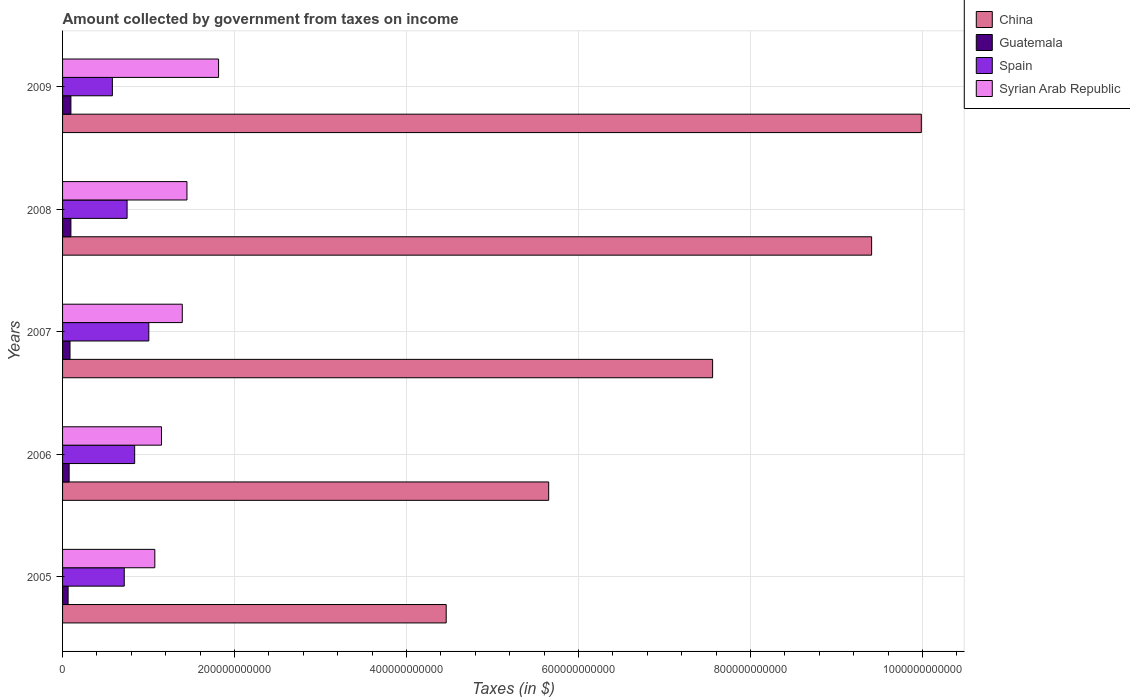How many different coloured bars are there?
Provide a short and direct response. 4. How many groups of bars are there?
Keep it short and to the point. 5. Are the number of bars on each tick of the Y-axis equal?
Make the answer very short. Yes. How many bars are there on the 5th tick from the top?
Offer a terse response. 4. How many bars are there on the 2nd tick from the bottom?
Ensure brevity in your answer.  4. What is the amount collected by government from taxes on income in Spain in 2005?
Ensure brevity in your answer.  7.17e+1. Across all years, what is the maximum amount collected by government from taxes on income in Syrian Arab Republic?
Offer a terse response. 1.81e+11. Across all years, what is the minimum amount collected by government from taxes on income in Guatemala?
Ensure brevity in your answer.  6.44e+09. In which year was the amount collected by government from taxes on income in Spain maximum?
Provide a succinct answer. 2007. In which year was the amount collected by government from taxes on income in China minimum?
Your response must be concise. 2005. What is the total amount collected by government from taxes on income in Spain in the graph?
Offer a terse response. 3.89e+11. What is the difference between the amount collected by government from taxes on income in Guatemala in 2006 and that in 2008?
Ensure brevity in your answer.  -2.05e+09. What is the difference between the amount collected by government from taxes on income in China in 2006 and the amount collected by government from taxes on income in Syrian Arab Republic in 2008?
Keep it short and to the point. 4.21e+11. What is the average amount collected by government from taxes on income in Guatemala per year?
Give a very brief answer. 8.43e+09. In the year 2008, what is the difference between the amount collected by government from taxes on income in Guatemala and amount collected by government from taxes on income in Spain?
Give a very brief answer. -6.53e+1. In how many years, is the amount collected by government from taxes on income in Guatemala greater than 640000000000 $?
Offer a terse response. 0. What is the ratio of the amount collected by government from taxes on income in Spain in 2005 to that in 2007?
Your response must be concise. 0.72. What is the difference between the highest and the second highest amount collected by government from taxes on income in Syrian Arab Republic?
Your response must be concise. 3.68e+1. What is the difference between the highest and the lowest amount collected by government from taxes on income in China?
Make the answer very short. 5.52e+11. What does the 2nd bar from the bottom in 2006 represents?
Provide a short and direct response. Guatemala. How many bars are there?
Your answer should be compact. 20. Are all the bars in the graph horizontal?
Make the answer very short. Yes. How many years are there in the graph?
Provide a short and direct response. 5. What is the difference between two consecutive major ticks on the X-axis?
Make the answer very short. 2.00e+11. Are the values on the major ticks of X-axis written in scientific E-notation?
Your response must be concise. No. Does the graph contain grids?
Offer a very short reply. Yes. How many legend labels are there?
Make the answer very short. 4. How are the legend labels stacked?
Give a very brief answer. Vertical. What is the title of the graph?
Offer a very short reply. Amount collected by government from taxes on income. Does "Hungary" appear as one of the legend labels in the graph?
Give a very brief answer. No. What is the label or title of the X-axis?
Make the answer very short. Taxes (in $). What is the Taxes (in $) in China in 2005?
Your answer should be very brief. 4.46e+11. What is the Taxes (in $) of Guatemala in 2005?
Ensure brevity in your answer.  6.44e+09. What is the Taxes (in $) of Spain in 2005?
Provide a succinct answer. 7.17e+1. What is the Taxes (in $) in Syrian Arab Republic in 2005?
Offer a terse response. 1.07e+11. What is the Taxes (in $) of China in 2006?
Your response must be concise. 5.65e+11. What is the Taxes (in $) in Guatemala in 2006?
Make the answer very short. 7.65e+09. What is the Taxes (in $) in Spain in 2006?
Provide a succinct answer. 8.38e+1. What is the Taxes (in $) of Syrian Arab Republic in 2006?
Provide a succinct answer. 1.15e+11. What is the Taxes (in $) of China in 2007?
Ensure brevity in your answer.  7.56e+11. What is the Taxes (in $) in Guatemala in 2007?
Offer a very short reply. 8.65e+09. What is the Taxes (in $) in Spain in 2007?
Ensure brevity in your answer.  1.00e+11. What is the Taxes (in $) of Syrian Arab Republic in 2007?
Give a very brief answer. 1.39e+11. What is the Taxes (in $) in China in 2008?
Your response must be concise. 9.41e+11. What is the Taxes (in $) in Guatemala in 2008?
Provide a succinct answer. 9.70e+09. What is the Taxes (in $) of Spain in 2008?
Your answer should be very brief. 7.50e+1. What is the Taxes (in $) of Syrian Arab Republic in 2008?
Your answer should be compact. 1.45e+11. What is the Taxes (in $) of China in 2009?
Give a very brief answer. 9.99e+11. What is the Taxes (in $) in Guatemala in 2009?
Provide a short and direct response. 9.71e+09. What is the Taxes (in $) of Spain in 2009?
Offer a very short reply. 5.79e+1. What is the Taxes (in $) in Syrian Arab Republic in 2009?
Keep it short and to the point. 1.81e+11. Across all years, what is the maximum Taxes (in $) in China?
Offer a terse response. 9.99e+11. Across all years, what is the maximum Taxes (in $) in Guatemala?
Your response must be concise. 9.71e+09. Across all years, what is the maximum Taxes (in $) in Spain?
Offer a very short reply. 1.00e+11. Across all years, what is the maximum Taxes (in $) of Syrian Arab Republic?
Your answer should be very brief. 1.81e+11. Across all years, what is the minimum Taxes (in $) of China?
Make the answer very short. 4.46e+11. Across all years, what is the minimum Taxes (in $) of Guatemala?
Offer a very short reply. 6.44e+09. Across all years, what is the minimum Taxes (in $) of Spain?
Provide a succinct answer. 5.79e+1. Across all years, what is the minimum Taxes (in $) of Syrian Arab Republic?
Your answer should be very brief. 1.07e+11. What is the total Taxes (in $) of China in the graph?
Offer a terse response. 3.71e+12. What is the total Taxes (in $) of Guatemala in the graph?
Your response must be concise. 4.21e+1. What is the total Taxes (in $) of Spain in the graph?
Your answer should be very brief. 3.89e+11. What is the total Taxes (in $) in Syrian Arab Republic in the graph?
Your answer should be compact. 6.88e+11. What is the difference between the Taxes (in $) of China in 2005 and that in 2006?
Your answer should be very brief. -1.19e+11. What is the difference between the Taxes (in $) of Guatemala in 2005 and that in 2006?
Provide a succinct answer. -1.21e+09. What is the difference between the Taxes (in $) in Spain in 2005 and that in 2006?
Offer a terse response. -1.21e+1. What is the difference between the Taxes (in $) of Syrian Arab Republic in 2005 and that in 2006?
Keep it short and to the point. -7.73e+09. What is the difference between the Taxes (in $) in China in 2005 and that in 2007?
Keep it short and to the point. -3.10e+11. What is the difference between the Taxes (in $) of Guatemala in 2005 and that in 2007?
Provide a short and direct response. -2.22e+09. What is the difference between the Taxes (in $) of Spain in 2005 and that in 2007?
Ensure brevity in your answer.  -2.86e+1. What is the difference between the Taxes (in $) in Syrian Arab Republic in 2005 and that in 2007?
Your answer should be very brief. -3.19e+1. What is the difference between the Taxes (in $) of China in 2005 and that in 2008?
Your response must be concise. -4.95e+11. What is the difference between the Taxes (in $) of Guatemala in 2005 and that in 2008?
Provide a short and direct response. -3.26e+09. What is the difference between the Taxes (in $) of Spain in 2005 and that in 2008?
Provide a short and direct response. -3.30e+09. What is the difference between the Taxes (in $) in Syrian Arab Republic in 2005 and that in 2008?
Your answer should be very brief. -3.73e+1. What is the difference between the Taxes (in $) in China in 2005 and that in 2009?
Your response must be concise. -5.52e+11. What is the difference between the Taxes (in $) of Guatemala in 2005 and that in 2009?
Make the answer very short. -3.27e+09. What is the difference between the Taxes (in $) of Spain in 2005 and that in 2009?
Make the answer very short. 1.38e+1. What is the difference between the Taxes (in $) in Syrian Arab Republic in 2005 and that in 2009?
Provide a succinct answer. -7.41e+1. What is the difference between the Taxes (in $) of China in 2006 and that in 2007?
Provide a succinct answer. -1.91e+11. What is the difference between the Taxes (in $) of Guatemala in 2006 and that in 2007?
Offer a very short reply. -1.01e+09. What is the difference between the Taxes (in $) in Spain in 2006 and that in 2007?
Ensure brevity in your answer.  -1.65e+1. What is the difference between the Taxes (in $) in Syrian Arab Republic in 2006 and that in 2007?
Provide a succinct answer. -2.42e+1. What is the difference between the Taxes (in $) of China in 2006 and that in 2008?
Provide a short and direct response. -3.76e+11. What is the difference between the Taxes (in $) of Guatemala in 2006 and that in 2008?
Keep it short and to the point. -2.05e+09. What is the difference between the Taxes (in $) of Spain in 2006 and that in 2008?
Offer a very short reply. 8.80e+09. What is the difference between the Taxes (in $) in Syrian Arab Republic in 2006 and that in 2008?
Provide a short and direct response. -2.96e+1. What is the difference between the Taxes (in $) in China in 2006 and that in 2009?
Your response must be concise. -4.33e+11. What is the difference between the Taxes (in $) in Guatemala in 2006 and that in 2009?
Offer a terse response. -2.06e+09. What is the difference between the Taxes (in $) of Spain in 2006 and that in 2009?
Provide a succinct answer. 2.59e+1. What is the difference between the Taxes (in $) in Syrian Arab Republic in 2006 and that in 2009?
Provide a succinct answer. -6.64e+1. What is the difference between the Taxes (in $) in China in 2007 and that in 2008?
Ensure brevity in your answer.  -1.85e+11. What is the difference between the Taxes (in $) in Guatemala in 2007 and that in 2008?
Provide a succinct answer. -1.04e+09. What is the difference between the Taxes (in $) in Spain in 2007 and that in 2008?
Keep it short and to the point. 2.53e+1. What is the difference between the Taxes (in $) in Syrian Arab Republic in 2007 and that in 2008?
Your response must be concise. -5.43e+09. What is the difference between the Taxes (in $) of China in 2007 and that in 2009?
Offer a terse response. -2.43e+11. What is the difference between the Taxes (in $) of Guatemala in 2007 and that in 2009?
Offer a terse response. -1.05e+09. What is the difference between the Taxes (in $) in Spain in 2007 and that in 2009?
Provide a succinct answer. 4.24e+1. What is the difference between the Taxes (in $) of Syrian Arab Republic in 2007 and that in 2009?
Your response must be concise. -4.22e+1. What is the difference between the Taxes (in $) in China in 2008 and that in 2009?
Make the answer very short. -5.78e+1. What is the difference between the Taxes (in $) in Guatemala in 2008 and that in 2009?
Provide a succinct answer. -7.40e+06. What is the difference between the Taxes (in $) in Spain in 2008 and that in 2009?
Offer a very short reply. 1.71e+1. What is the difference between the Taxes (in $) in Syrian Arab Republic in 2008 and that in 2009?
Ensure brevity in your answer.  -3.68e+1. What is the difference between the Taxes (in $) of China in 2005 and the Taxes (in $) of Guatemala in 2006?
Offer a terse response. 4.38e+11. What is the difference between the Taxes (in $) of China in 2005 and the Taxes (in $) of Spain in 2006?
Provide a succinct answer. 3.62e+11. What is the difference between the Taxes (in $) in China in 2005 and the Taxes (in $) in Syrian Arab Republic in 2006?
Provide a short and direct response. 3.31e+11. What is the difference between the Taxes (in $) of Guatemala in 2005 and the Taxes (in $) of Spain in 2006?
Your answer should be compact. -7.74e+1. What is the difference between the Taxes (in $) in Guatemala in 2005 and the Taxes (in $) in Syrian Arab Republic in 2006?
Keep it short and to the point. -1.09e+11. What is the difference between the Taxes (in $) in Spain in 2005 and the Taxes (in $) in Syrian Arab Republic in 2006?
Give a very brief answer. -4.33e+1. What is the difference between the Taxes (in $) in China in 2005 and the Taxes (in $) in Guatemala in 2007?
Give a very brief answer. 4.37e+11. What is the difference between the Taxes (in $) of China in 2005 and the Taxes (in $) of Spain in 2007?
Make the answer very short. 3.46e+11. What is the difference between the Taxes (in $) of China in 2005 and the Taxes (in $) of Syrian Arab Republic in 2007?
Give a very brief answer. 3.07e+11. What is the difference between the Taxes (in $) of Guatemala in 2005 and the Taxes (in $) of Spain in 2007?
Your answer should be very brief. -9.39e+1. What is the difference between the Taxes (in $) in Guatemala in 2005 and the Taxes (in $) in Syrian Arab Republic in 2007?
Your answer should be compact. -1.33e+11. What is the difference between the Taxes (in $) in Spain in 2005 and the Taxes (in $) in Syrian Arab Republic in 2007?
Make the answer very short. -6.75e+1. What is the difference between the Taxes (in $) of China in 2005 and the Taxes (in $) of Guatemala in 2008?
Keep it short and to the point. 4.36e+11. What is the difference between the Taxes (in $) in China in 2005 and the Taxes (in $) in Spain in 2008?
Provide a succinct answer. 3.71e+11. What is the difference between the Taxes (in $) in China in 2005 and the Taxes (in $) in Syrian Arab Republic in 2008?
Your answer should be very brief. 3.01e+11. What is the difference between the Taxes (in $) of Guatemala in 2005 and the Taxes (in $) of Spain in 2008?
Make the answer very short. -6.86e+1. What is the difference between the Taxes (in $) in Guatemala in 2005 and the Taxes (in $) in Syrian Arab Republic in 2008?
Ensure brevity in your answer.  -1.38e+11. What is the difference between the Taxes (in $) of Spain in 2005 and the Taxes (in $) of Syrian Arab Republic in 2008?
Provide a succinct answer. -7.29e+1. What is the difference between the Taxes (in $) of China in 2005 and the Taxes (in $) of Guatemala in 2009?
Your answer should be very brief. 4.36e+11. What is the difference between the Taxes (in $) in China in 2005 and the Taxes (in $) in Spain in 2009?
Your answer should be very brief. 3.88e+11. What is the difference between the Taxes (in $) of China in 2005 and the Taxes (in $) of Syrian Arab Republic in 2009?
Keep it short and to the point. 2.65e+11. What is the difference between the Taxes (in $) in Guatemala in 2005 and the Taxes (in $) in Spain in 2009?
Keep it short and to the point. -5.15e+1. What is the difference between the Taxes (in $) in Guatemala in 2005 and the Taxes (in $) in Syrian Arab Republic in 2009?
Provide a short and direct response. -1.75e+11. What is the difference between the Taxes (in $) in Spain in 2005 and the Taxes (in $) in Syrian Arab Republic in 2009?
Offer a terse response. -1.10e+11. What is the difference between the Taxes (in $) of China in 2006 and the Taxes (in $) of Guatemala in 2007?
Offer a terse response. 5.57e+11. What is the difference between the Taxes (in $) in China in 2006 and the Taxes (in $) in Spain in 2007?
Offer a terse response. 4.65e+11. What is the difference between the Taxes (in $) of China in 2006 and the Taxes (in $) of Syrian Arab Republic in 2007?
Give a very brief answer. 4.26e+11. What is the difference between the Taxes (in $) of Guatemala in 2006 and the Taxes (in $) of Spain in 2007?
Your answer should be very brief. -9.26e+1. What is the difference between the Taxes (in $) in Guatemala in 2006 and the Taxes (in $) in Syrian Arab Republic in 2007?
Offer a terse response. -1.32e+11. What is the difference between the Taxes (in $) in Spain in 2006 and the Taxes (in $) in Syrian Arab Republic in 2007?
Your answer should be compact. -5.54e+1. What is the difference between the Taxes (in $) of China in 2006 and the Taxes (in $) of Guatemala in 2008?
Make the answer very short. 5.56e+11. What is the difference between the Taxes (in $) in China in 2006 and the Taxes (in $) in Spain in 2008?
Provide a succinct answer. 4.90e+11. What is the difference between the Taxes (in $) of China in 2006 and the Taxes (in $) of Syrian Arab Republic in 2008?
Provide a succinct answer. 4.21e+11. What is the difference between the Taxes (in $) in Guatemala in 2006 and the Taxes (in $) in Spain in 2008?
Your answer should be compact. -6.74e+1. What is the difference between the Taxes (in $) in Guatemala in 2006 and the Taxes (in $) in Syrian Arab Republic in 2008?
Ensure brevity in your answer.  -1.37e+11. What is the difference between the Taxes (in $) in Spain in 2006 and the Taxes (in $) in Syrian Arab Republic in 2008?
Provide a succinct answer. -6.08e+1. What is the difference between the Taxes (in $) of China in 2006 and the Taxes (in $) of Guatemala in 2009?
Provide a short and direct response. 5.56e+11. What is the difference between the Taxes (in $) in China in 2006 and the Taxes (in $) in Spain in 2009?
Your answer should be very brief. 5.07e+11. What is the difference between the Taxes (in $) in China in 2006 and the Taxes (in $) in Syrian Arab Republic in 2009?
Offer a terse response. 3.84e+11. What is the difference between the Taxes (in $) of Guatemala in 2006 and the Taxes (in $) of Spain in 2009?
Keep it short and to the point. -5.03e+1. What is the difference between the Taxes (in $) of Guatemala in 2006 and the Taxes (in $) of Syrian Arab Republic in 2009?
Keep it short and to the point. -1.74e+11. What is the difference between the Taxes (in $) in Spain in 2006 and the Taxes (in $) in Syrian Arab Republic in 2009?
Make the answer very short. -9.76e+1. What is the difference between the Taxes (in $) of China in 2007 and the Taxes (in $) of Guatemala in 2008?
Offer a very short reply. 7.46e+11. What is the difference between the Taxes (in $) of China in 2007 and the Taxes (in $) of Spain in 2008?
Make the answer very short. 6.81e+11. What is the difference between the Taxes (in $) of China in 2007 and the Taxes (in $) of Syrian Arab Republic in 2008?
Offer a very short reply. 6.11e+11. What is the difference between the Taxes (in $) in Guatemala in 2007 and the Taxes (in $) in Spain in 2008?
Make the answer very short. -6.64e+1. What is the difference between the Taxes (in $) of Guatemala in 2007 and the Taxes (in $) of Syrian Arab Republic in 2008?
Give a very brief answer. -1.36e+11. What is the difference between the Taxes (in $) of Spain in 2007 and the Taxes (in $) of Syrian Arab Republic in 2008?
Provide a short and direct response. -4.43e+1. What is the difference between the Taxes (in $) in China in 2007 and the Taxes (in $) in Guatemala in 2009?
Provide a short and direct response. 7.46e+11. What is the difference between the Taxes (in $) in China in 2007 and the Taxes (in $) in Spain in 2009?
Make the answer very short. 6.98e+11. What is the difference between the Taxes (in $) of China in 2007 and the Taxes (in $) of Syrian Arab Republic in 2009?
Your response must be concise. 5.74e+11. What is the difference between the Taxes (in $) in Guatemala in 2007 and the Taxes (in $) in Spain in 2009?
Give a very brief answer. -4.93e+1. What is the difference between the Taxes (in $) of Guatemala in 2007 and the Taxes (in $) of Syrian Arab Republic in 2009?
Give a very brief answer. -1.73e+11. What is the difference between the Taxes (in $) of Spain in 2007 and the Taxes (in $) of Syrian Arab Republic in 2009?
Offer a very short reply. -8.11e+1. What is the difference between the Taxes (in $) of China in 2008 and the Taxes (in $) of Guatemala in 2009?
Your answer should be compact. 9.31e+11. What is the difference between the Taxes (in $) in China in 2008 and the Taxes (in $) in Spain in 2009?
Provide a succinct answer. 8.83e+11. What is the difference between the Taxes (in $) of China in 2008 and the Taxes (in $) of Syrian Arab Republic in 2009?
Provide a short and direct response. 7.59e+11. What is the difference between the Taxes (in $) of Guatemala in 2008 and the Taxes (in $) of Spain in 2009?
Keep it short and to the point. -4.82e+1. What is the difference between the Taxes (in $) in Guatemala in 2008 and the Taxes (in $) in Syrian Arab Republic in 2009?
Provide a short and direct response. -1.72e+11. What is the difference between the Taxes (in $) in Spain in 2008 and the Taxes (in $) in Syrian Arab Republic in 2009?
Provide a succinct answer. -1.06e+11. What is the average Taxes (in $) of China per year?
Make the answer very short. 7.41e+11. What is the average Taxes (in $) in Guatemala per year?
Provide a short and direct response. 8.43e+09. What is the average Taxes (in $) of Spain per year?
Your response must be concise. 7.78e+1. What is the average Taxes (in $) in Syrian Arab Republic per year?
Keep it short and to the point. 1.38e+11. In the year 2005, what is the difference between the Taxes (in $) of China and Taxes (in $) of Guatemala?
Make the answer very short. 4.40e+11. In the year 2005, what is the difference between the Taxes (in $) of China and Taxes (in $) of Spain?
Your answer should be compact. 3.74e+11. In the year 2005, what is the difference between the Taxes (in $) in China and Taxes (in $) in Syrian Arab Republic?
Offer a terse response. 3.39e+11. In the year 2005, what is the difference between the Taxes (in $) of Guatemala and Taxes (in $) of Spain?
Offer a very short reply. -6.53e+1. In the year 2005, what is the difference between the Taxes (in $) in Guatemala and Taxes (in $) in Syrian Arab Republic?
Offer a terse response. -1.01e+11. In the year 2005, what is the difference between the Taxes (in $) of Spain and Taxes (in $) of Syrian Arab Republic?
Your answer should be very brief. -3.56e+1. In the year 2006, what is the difference between the Taxes (in $) of China and Taxes (in $) of Guatemala?
Your answer should be compact. 5.58e+11. In the year 2006, what is the difference between the Taxes (in $) in China and Taxes (in $) in Spain?
Provide a succinct answer. 4.81e+11. In the year 2006, what is the difference between the Taxes (in $) in China and Taxes (in $) in Syrian Arab Republic?
Keep it short and to the point. 4.50e+11. In the year 2006, what is the difference between the Taxes (in $) in Guatemala and Taxes (in $) in Spain?
Offer a very short reply. -7.62e+1. In the year 2006, what is the difference between the Taxes (in $) in Guatemala and Taxes (in $) in Syrian Arab Republic?
Your answer should be very brief. -1.07e+11. In the year 2006, what is the difference between the Taxes (in $) of Spain and Taxes (in $) of Syrian Arab Republic?
Provide a succinct answer. -3.12e+1. In the year 2007, what is the difference between the Taxes (in $) of China and Taxes (in $) of Guatemala?
Make the answer very short. 7.47e+11. In the year 2007, what is the difference between the Taxes (in $) of China and Taxes (in $) of Spain?
Your answer should be very brief. 6.56e+11. In the year 2007, what is the difference between the Taxes (in $) of China and Taxes (in $) of Syrian Arab Republic?
Provide a short and direct response. 6.17e+11. In the year 2007, what is the difference between the Taxes (in $) of Guatemala and Taxes (in $) of Spain?
Offer a terse response. -9.16e+1. In the year 2007, what is the difference between the Taxes (in $) of Guatemala and Taxes (in $) of Syrian Arab Republic?
Your response must be concise. -1.31e+11. In the year 2007, what is the difference between the Taxes (in $) of Spain and Taxes (in $) of Syrian Arab Republic?
Ensure brevity in your answer.  -3.89e+1. In the year 2008, what is the difference between the Taxes (in $) in China and Taxes (in $) in Guatemala?
Ensure brevity in your answer.  9.31e+11. In the year 2008, what is the difference between the Taxes (in $) in China and Taxes (in $) in Spain?
Your answer should be compact. 8.66e+11. In the year 2008, what is the difference between the Taxes (in $) of China and Taxes (in $) of Syrian Arab Republic?
Make the answer very short. 7.96e+11. In the year 2008, what is the difference between the Taxes (in $) in Guatemala and Taxes (in $) in Spain?
Offer a terse response. -6.53e+1. In the year 2008, what is the difference between the Taxes (in $) in Guatemala and Taxes (in $) in Syrian Arab Republic?
Provide a succinct answer. -1.35e+11. In the year 2008, what is the difference between the Taxes (in $) of Spain and Taxes (in $) of Syrian Arab Republic?
Your response must be concise. -6.96e+1. In the year 2009, what is the difference between the Taxes (in $) of China and Taxes (in $) of Guatemala?
Make the answer very short. 9.89e+11. In the year 2009, what is the difference between the Taxes (in $) of China and Taxes (in $) of Spain?
Make the answer very short. 9.41e+11. In the year 2009, what is the difference between the Taxes (in $) of China and Taxes (in $) of Syrian Arab Republic?
Give a very brief answer. 8.17e+11. In the year 2009, what is the difference between the Taxes (in $) in Guatemala and Taxes (in $) in Spain?
Keep it short and to the point. -4.82e+1. In the year 2009, what is the difference between the Taxes (in $) in Guatemala and Taxes (in $) in Syrian Arab Republic?
Your response must be concise. -1.72e+11. In the year 2009, what is the difference between the Taxes (in $) in Spain and Taxes (in $) in Syrian Arab Republic?
Your response must be concise. -1.23e+11. What is the ratio of the Taxes (in $) of China in 2005 to that in 2006?
Give a very brief answer. 0.79. What is the ratio of the Taxes (in $) of Guatemala in 2005 to that in 2006?
Your response must be concise. 0.84. What is the ratio of the Taxes (in $) in Spain in 2005 to that in 2006?
Keep it short and to the point. 0.86. What is the ratio of the Taxes (in $) of Syrian Arab Republic in 2005 to that in 2006?
Your response must be concise. 0.93. What is the ratio of the Taxes (in $) of China in 2005 to that in 2007?
Provide a succinct answer. 0.59. What is the ratio of the Taxes (in $) of Guatemala in 2005 to that in 2007?
Provide a short and direct response. 0.74. What is the ratio of the Taxes (in $) in Spain in 2005 to that in 2007?
Offer a very short reply. 0.72. What is the ratio of the Taxes (in $) in Syrian Arab Republic in 2005 to that in 2007?
Your response must be concise. 0.77. What is the ratio of the Taxes (in $) of China in 2005 to that in 2008?
Provide a succinct answer. 0.47. What is the ratio of the Taxes (in $) in Guatemala in 2005 to that in 2008?
Your response must be concise. 0.66. What is the ratio of the Taxes (in $) in Spain in 2005 to that in 2008?
Your response must be concise. 0.96. What is the ratio of the Taxes (in $) in Syrian Arab Republic in 2005 to that in 2008?
Provide a short and direct response. 0.74. What is the ratio of the Taxes (in $) in China in 2005 to that in 2009?
Ensure brevity in your answer.  0.45. What is the ratio of the Taxes (in $) in Guatemala in 2005 to that in 2009?
Your response must be concise. 0.66. What is the ratio of the Taxes (in $) in Spain in 2005 to that in 2009?
Give a very brief answer. 1.24. What is the ratio of the Taxes (in $) of Syrian Arab Republic in 2005 to that in 2009?
Your response must be concise. 0.59. What is the ratio of the Taxes (in $) in China in 2006 to that in 2007?
Offer a very short reply. 0.75. What is the ratio of the Taxes (in $) of Guatemala in 2006 to that in 2007?
Make the answer very short. 0.88. What is the ratio of the Taxes (in $) of Spain in 2006 to that in 2007?
Make the answer very short. 0.84. What is the ratio of the Taxes (in $) of Syrian Arab Republic in 2006 to that in 2007?
Keep it short and to the point. 0.83. What is the ratio of the Taxes (in $) of China in 2006 to that in 2008?
Give a very brief answer. 0.6. What is the ratio of the Taxes (in $) of Guatemala in 2006 to that in 2008?
Offer a terse response. 0.79. What is the ratio of the Taxes (in $) in Spain in 2006 to that in 2008?
Your answer should be very brief. 1.12. What is the ratio of the Taxes (in $) in Syrian Arab Republic in 2006 to that in 2008?
Ensure brevity in your answer.  0.8. What is the ratio of the Taxes (in $) of China in 2006 to that in 2009?
Your answer should be very brief. 0.57. What is the ratio of the Taxes (in $) of Guatemala in 2006 to that in 2009?
Ensure brevity in your answer.  0.79. What is the ratio of the Taxes (in $) of Spain in 2006 to that in 2009?
Make the answer very short. 1.45. What is the ratio of the Taxes (in $) in Syrian Arab Republic in 2006 to that in 2009?
Offer a terse response. 0.63. What is the ratio of the Taxes (in $) of China in 2007 to that in 2008?
Your answer should be very brief. 0.8. What is the ratio of the Taxes (in $) of Guatemala in 2007 to that in 2008?
Give a very brief answer. 0.89. What is the ratio of the Taxes (in $) of Spain in 2007 to that in 2008?
Provide a succinct answer. 1.34. What is the ratio of the Taxes (in $) of Syrian Arab Republic in 2007 to that in 2008?
Make the answer very short. 0.96. What is the ratio of the Taxes (in $) in China in 2007 to that in 2009?
Your answer should be very brief. 0.76. What is the ratio of the Taxes (in $) of Guatemala in 2007 to that in 2009?
Keep it short and to the point. 0.89. What is the ratio of the Taxes (in $) in Spain in 2007 to that in 2009?
Provide a succinct answer. 1.73. What is the ratio of the Taxes (in $) in Syrian Arab Republic in 2007 to that in 2009?
Provide a short and direct response. 0.77. What is the ratio of the Taxes (in $) of China in 2008 to that in 2009?
Your answer should be compact. 0.94. What is the ratio of the Taxes (in $) in Guatemala in 2008 to that in 2009?
Provide a succinct answer. 1. What is the ratio of the Taxes (in $) in Spain in 2008 to that in 2009?
Your answer should be very brief. 1.3. What is the ratio of the Taxes (in $) of Syrian Arab Republic in 2008 to that in 2009?
Your response must be concise. 0.8. What is the difference between the highest and the second highest Taxes (in $) in China?
Make the answer very short. 5.78e+1. What is the difference between the highest and the second highest Taxes (in $) in Guatemala?
Provide a short and direct response. 7.40e+06. What is the difference between the highest and the second highest Taxes (in $) of Spain?
Keep it short and to the point. 1.65e+1. What is the difference between the highest and the second highest Taxes (in $) of Syrian Arab Republic?
Provide a short and direct response. 3.68e+1. What is the difference between the highest and the lowest Taxes (in $) in China?
Offer a very short reply. 5.52e+11. What is the difference between the highest and the lowest Taxes (in $) of Guatemala?
Make the answer very short. 3.27e+09. What is the difference between the highest and the lowest Taxes (in $) in Spain?
Ensure brevity in your answer.  4.24e+1. What is the difference between the highest and the lowest Taxes (in $) in Syrian Arab Republic?
Ensure brevity in your answer.  7.41e+1. 